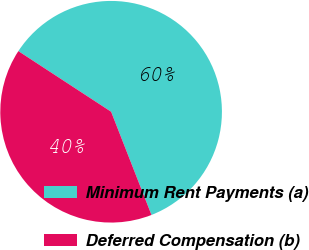Convert chart. <chart><loc_0><loc_0><loc_500><loc_500><pie_chart><fcel>Minimum Rent Payments (a)<fcel>Deferred Compensation (b)<nl><fcel>59.85%<fcel>40.15%<nl></chart> 